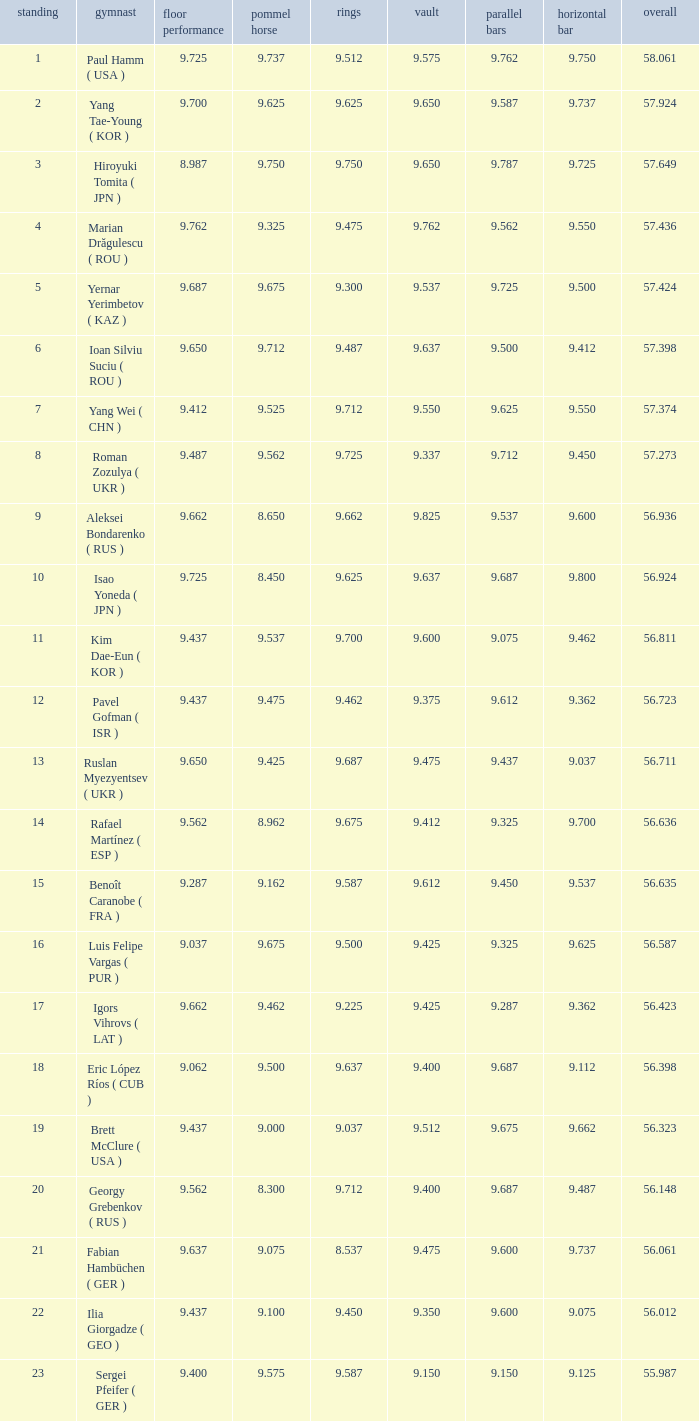Help me parse the entirety of this table. {'header': ['standing', 'gymnast', 'floor performance', 'pommel horse', 'rings', 'vault', 'parallel bars', 'horizontal bar', 'overall'], 'rows': [['1', 'Paul Hamm ( USA )', '9.725', '9.737', '9.512', '9.575', '9.762', '9.750', '58.061'], ['2', 'Yang Tae-Young ( KOR )', '9.700', '9.625', '9.625', '9.650', '9.587', '9.737', '57.924'], ['3', 'Hiroyuki Tomita ( JPN )', '8.987', '9.750', '9.750', '9.650', '9.787', '9.725', '57.649'], ['4', 'Marian Drăgulescu ( ROU )', '9.762', '9.325', '9.475', '9.762', '9.562', '9.550', '57.436'], ['5', 'Yernar Yerimbetov ( KAZ )', '9.687', '9.675', '9.300', '9.537', '9.725', '9.500', '57.424'], ['6', 'Ioan Silviu Suciu ( ROU )', '9.650', '9.712', '9.487', '9.637', '9.500', '9.412', '57.398'], ['7', 'Yang Wei ( CHN )', '9.412', '9.525', '9.712', '9.550', '9.625', '9.550', '57.374'], ['8', 'Roman Zozulya ( UKR )', '9.487', '9.562', '9.725', '9.337', '9.712', '9.450', '57.273'], ['9', 'Aleksei Bondarenko ( RUS )', '9.662', '8.650', '9.662', '9.825', '9.537', '9.600', '56.936'], ['10', 'Isao Yoneda ( JPN )', '9.725', '8.450', '9.625', '9.637', '9.687', '9.800', '56.924'], ['11', 'Kim Dae-Eun ( KOR )', '9.437', '9.537', '9.700', '9.600', '9.075', '9.462', '56.811'], ['12', 'Pavel Gofman ( ISR )', '9.437', '9.475', '9.462', '9.375', '9.612', '9.362', '56.723'], ['13', 'Ruslan Myezyentsev ( UKR )', '9.650', '9.425', '9.687', '9.475', '9.437', '9.037', '56.711'], ['14', 'Rafael Martínez ( ESP )', '9.562', '8.962', '9.675', '9.412', '9.325', '9.700', '56.636'], ['15', 'Benoît Caranobe ( FRA )', '9.287', '9.162', '9.587', '9.612', '9.450', '9.537', '56.635'], ['16', 'Luis Felipe Vargas ( PUR )', '9.037', '9.675', '9.500', '9.425', '9.325', '9.625', '56.587'], ['17', 'Igors Vihrovs ( LAT )', '9.662', '9.462', '9.225', '9.425', '9.287', '9.362', '56.423'], ['18', 'Eric López Ríos ( CUB )', '9.062', '9.500', '9.637', '9.400', '9.687', '9.112', '56.398'], ['19', 'Brett McClure ( USA )', '9.437', '9.000', '9.037', '9.512', '9.675', '9.662', '56.323'], ['20', 'Georgy Grebenkov ( RUS )', '9.562', '8.300', '9.712', '9.400', '9.687', '9.487', '56.148'], ['21', 'Fabian Hambüchen ( GER )', '9.637', '9.075', '8.537', '9.475', '9.600', '9.737', '56.061'], ['22', 'Ilia Giorgadze ( GEO )', '9.437', '9.100', '9.450', '9.350', '9.600', '9.075', '56.012'], ['23', 'Sergei Pfeifer ( GER )', '9.400', '9.575', '9.587', '9.150', '9.150', '9.125', '55.987']]} What is the total score when the score for floor exercise was 9.287? 56.635. 